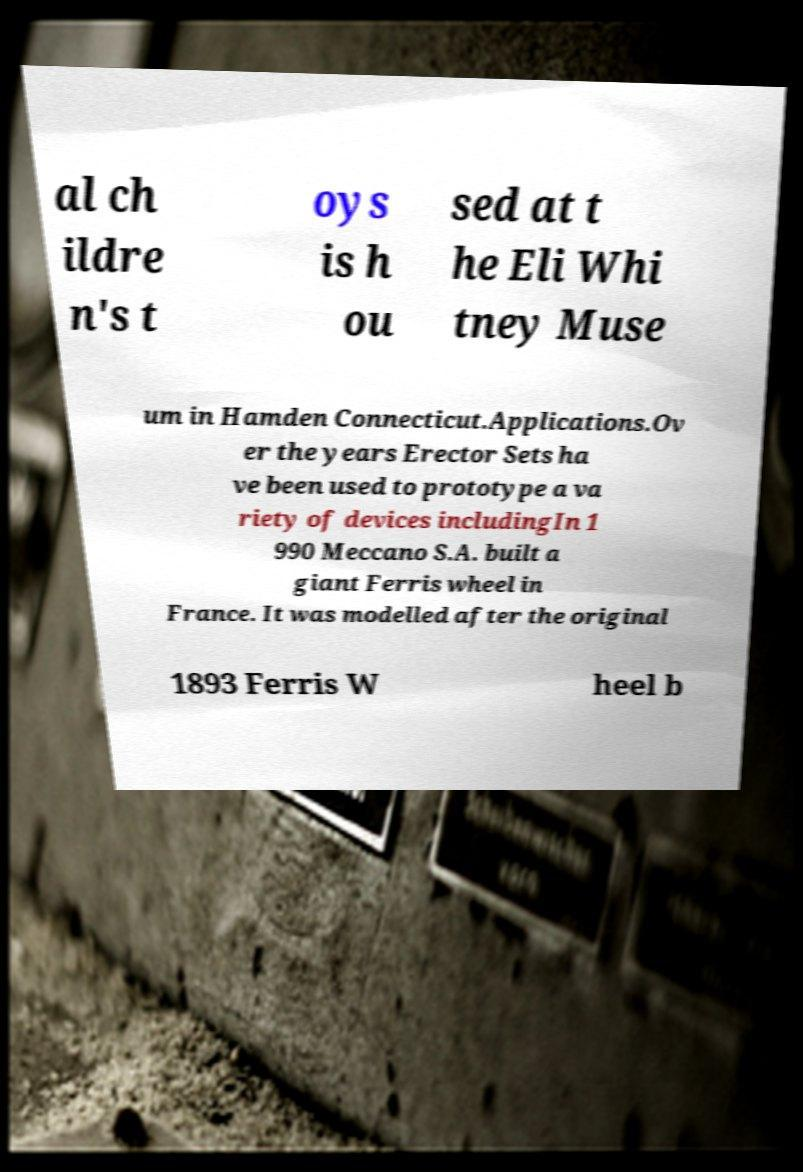Can you accurately transcribe the text from the provided image for me? al ch ildre n's t oys is h ou sed at t he Eli Whi tney Muse um in Hamden Connecticut.Applications.Ov er the years Erector Sets ha ve been used to prototype a va riety of devices includingIn 1 990 Meccano S.A. built a giant Ferris wheel in France. It was modelled after the original 1893 Ferris W heel b 